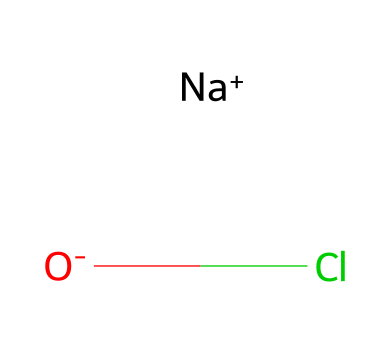What is the name of the chemical represented here? The structure corresponds to sodium hypochlorite, which consists of sodium (Na), oxygen (O), and chlorine (Cl) in its composition.
Answer: sodium hypochlorite How many atoms are present in this chemical? The SMILES representation includes two sodium ions, one oxygen, and one chlorine atom, totaling four atoms in the molecule.
Answer: four What is the charge of the chlorine in this structure? In the SMILES representation, chlorine is shown to be part of a negatively charged hypochlorite ion, which implies a negative charge associated with it.
Answer: negative What role does sodium play in this compound? Sodium in this compound acts as a counterion to balance the negative charge of the hypochlorite ion, contributing to the overall neutrality of the molecule.
Answer: counterion Is this chemical an example of a halogen compound? Yes, the presence of chlorine, a member of the halogen group, in the structure indicates that this is indeed a halogen compound.
Answer: yes What property of chlorine contributes to the disinfectant capabilities of this substance? Chlorine is known for its strong oxidative properties, which allow it to effectively kill bacteria and other pathogens, making it crucial for disinfection.
Answer: oxidative properties 